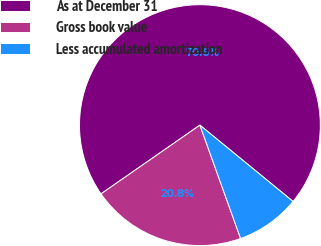Convert chart to OTSL. <chart><loc_0><loc_0><loc_500><loc_500><pie_chart><fcel>As at December 31<fcel>Gross book value<fcel>Less accumulated amortization<nl><fcel>70.59%<fcel>20.82%<fcel>8.59%<nl></chart> 